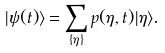<formula> <loc_0><loc_0><loc_500><loc_500>| \psi ( t ) \rangle = \sum _ { \{ \eta \} } p ( \eta , t ) | \eta \rangle .</formula> 